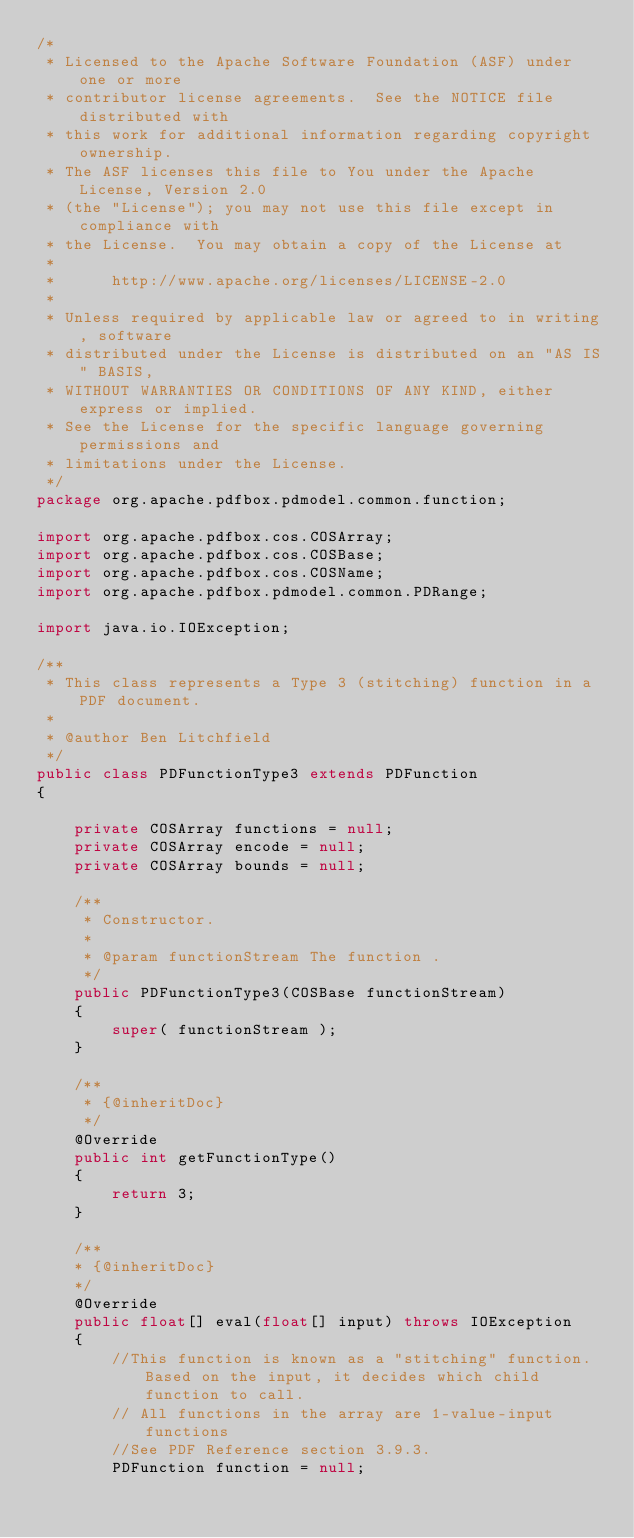Convert code to text. <code><loc_0><loc_0><loc_500><loc_500><_Java_>/*
 * Licensed to the Apache Software Foundation (ASF) under one or more
 * contributor license agreements.  See the NOTICE file distributed with
 * this work for additional information regarding copyright ownership.
 * The ASF licenses this file to You under the Apache License, Version 2.0
 * (the "License"); you may not use this file except in compliance with
 * the License.  You may obtain a copy of the License at
 *
 *      http://www.apache.org/licenses/LICENSE-2.0
 *
 * Unless required by applicable law or agreed to in writing, software
 * distributed under the License is distributed on an "AS IS" BASIS,
 * WITHOUT WARRANTIES OR CONDITIONS OF ANY KIND, either express or implied.
 * See the License for the specific language governing permissions and
 * limitations under the License.
 */
package org.apache.pdfbox.pdmodel.common.function;

import org.apache.pdfbox.cos.COSArray;
import org.apache.pdfbox.cos.COSBase;
import org.apache.pdfbox.cos.COSName;
import org.apache.pdfbox.pdmodel.common.PDRange;

import java.io.IOException;

/**
 * This class represents a Type 3 (stitching) function in a PDF document.
 *
 * @author Ben Litchfield
 */
public class PDFunctionType3 extends PDFunction
{

    private COSArray functions = null;
    private COSArray encode = null;
    private COSArray bounds = null;
    
    /**
     * Constructor.
     *
     * @param functionStream The function .
     */
    public PDFunctionType3(COSBase functionStream)
    {
        super( functionStream );
    }

    /**
     * {@inheritDoc}
     */
    @Override
    public int getFunctionType()
    {
        return 3;
    }
    
    /**
    * {@inheritDoc}
    */
    @Override
    public float[] eval(float[] input) throws IOException
    {
        //This function is known as a "stitching" function. Based on the input, it decides which child function to call.
        // All functions in the array are 1-value-input functions
        //See PDF Reference section 3.9.3.
        PDFunction function = null;</code> 